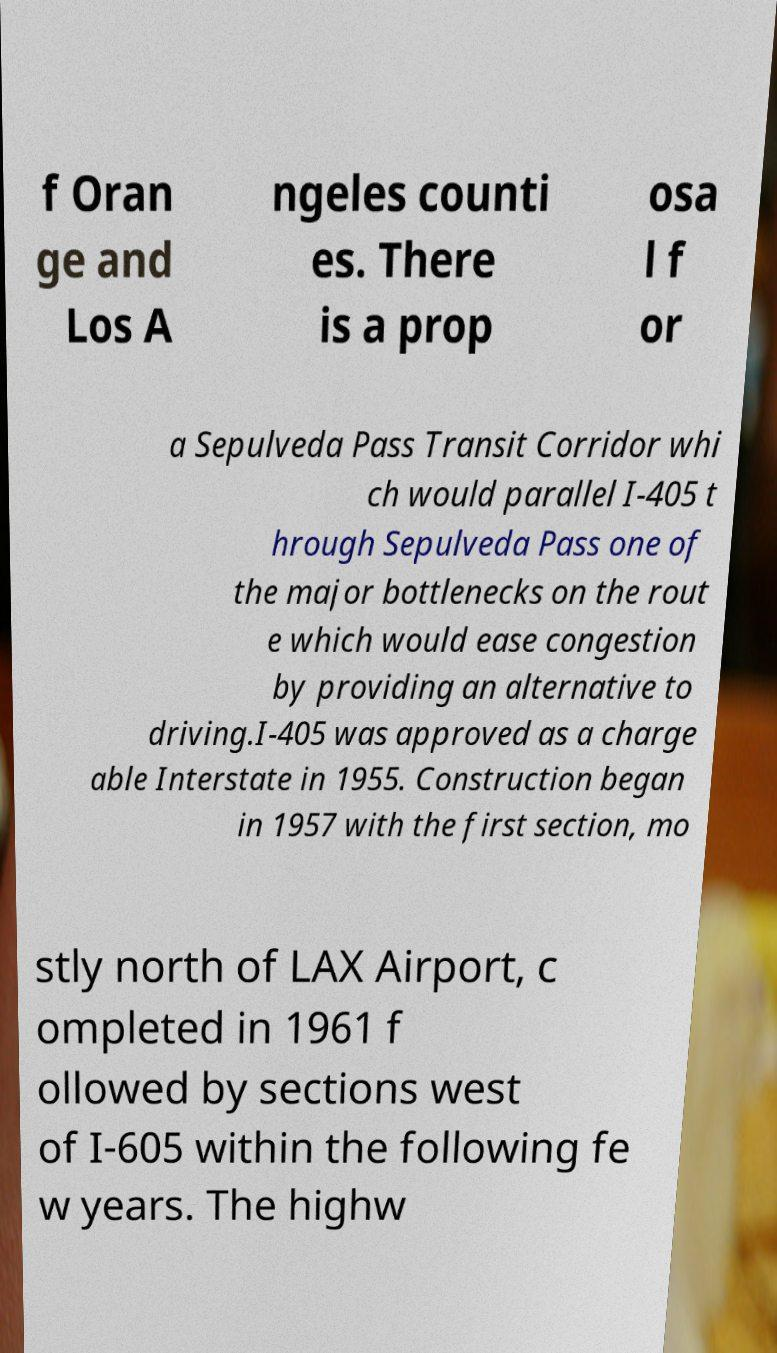I need the written content from this picture converted into text. Can you do that? f Oran ge and Los A ngeles counti es. There is a prop osa l f or a Sepulveda Pass Transit Corridor whi ch would parallel I-405 t hrough Sepulveda Pass one of the major bottlenecks on the rout e which would ease congestion by providing an alternative to driving.I-405 was approved as a charge able Interstate in 1955. Construction began in 1957 with the first section, mo stly north of LAX Airport, c ompleted in 1961 f ollowed by sections west of I-605 within the following fe w years. The highw 